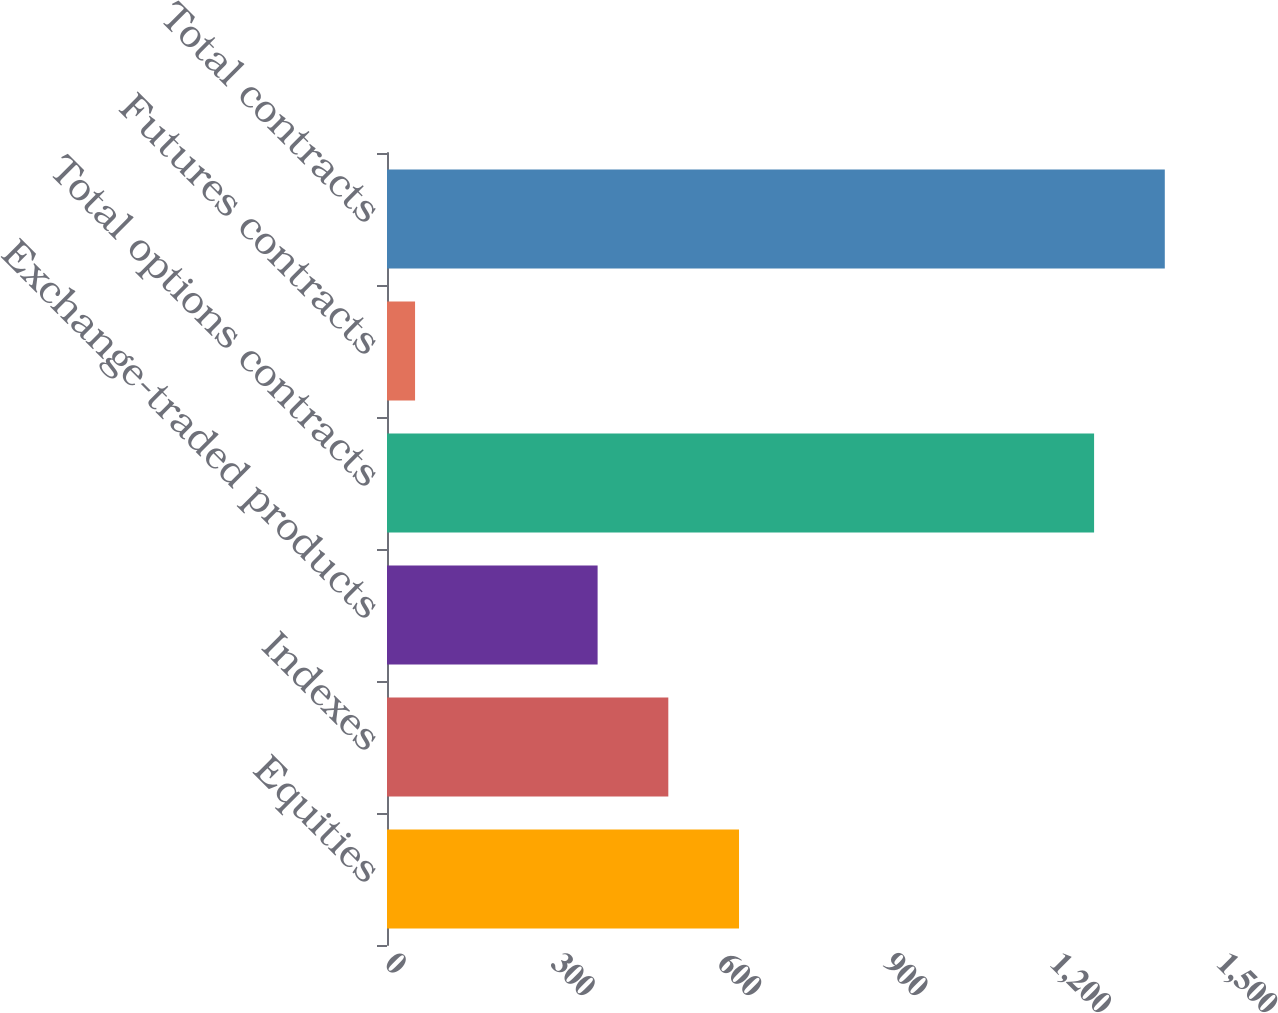Convert chart. <chart><loc_0><loc_0><loc_500><loc_500><bar_chart><fcel>Equities<fcel>Indexes<fcel>Exchange-traded products<fcel>Total options contracts<fcel>Futures contracts<fcel>Total contracts<nl><fcel>634.66<fcel>507.18<fcel>379.7<fcel>1274.8<fcel>50.6<fcel>1402.28<nl></chart> 